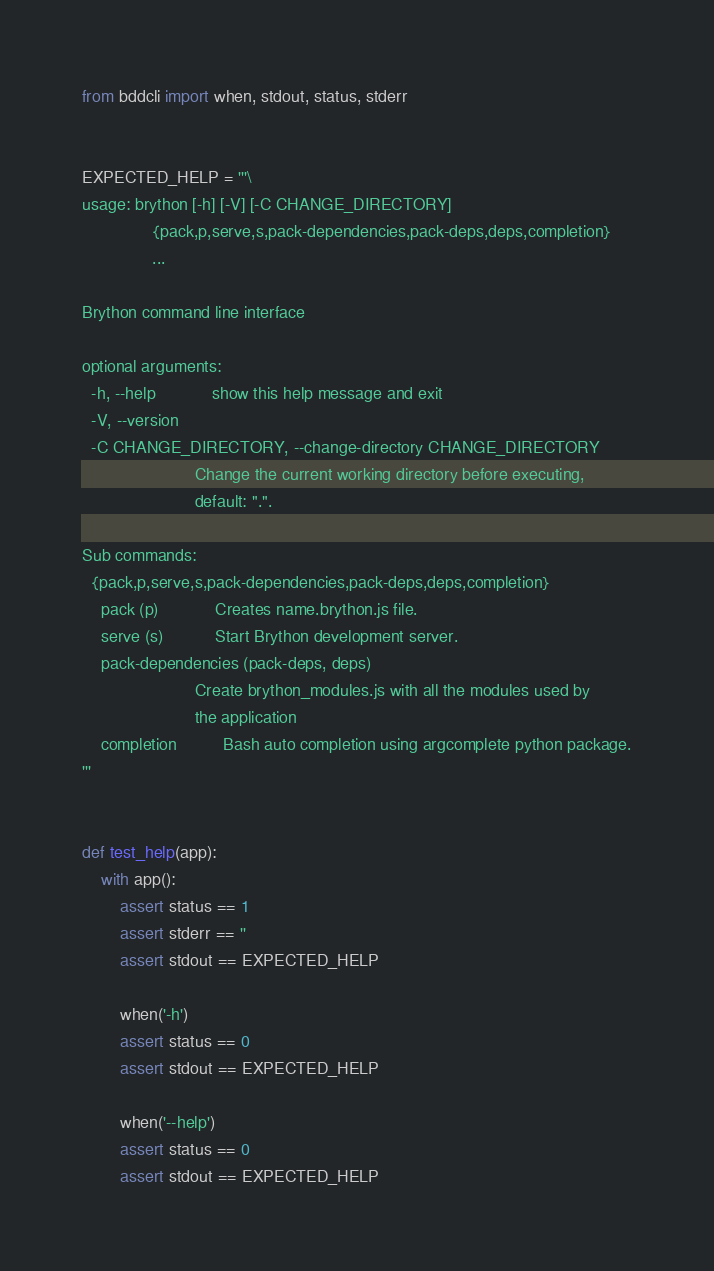<code> <loc_0><loc_0><loc_500><loc_500><_Python_>from bddcli import when, stdout, status, stderr


EXPECTED_HELP = '''\
usage: brython [-h] [-V] [-C CHANGE_DIRECTORY]
               {pack,p,serve,s,pack-dependencies,pack-deps,deps,completion}
               ...

Brython command line interface

optional arguments:
  -h, --help            show this help message and exit
  -V, --version
  -C CHANGE_DIRECTORY, --change-directory CHANGE_DIRECTORY
                        Change the current working directory before executing,
                        default: ".".

Sub commands:
  {pack,p,serve,s,pack-dependencies,pack-deps,deps,completion}
    pack (p)            Creates name.brython.js file.
    serve (s)           Start Brython development server.
    pack-dependencies (pack-deps, deps)
                        Create brython_modules.js with all the modules used by
                        the application
    completion          Bash auto completion using argcomplete python package.
'''


def test_help(app):
    with app():
        assert status == 1
        assert stderr == ''
        assert stdout == EXPECTED_HELP

        when('-h')
        assert status == 0
        assert stdout == EXPECTED_HELP

        when('--help')
        assert status == 0
        assert stdout == EXPECTED_HELP
</code> 